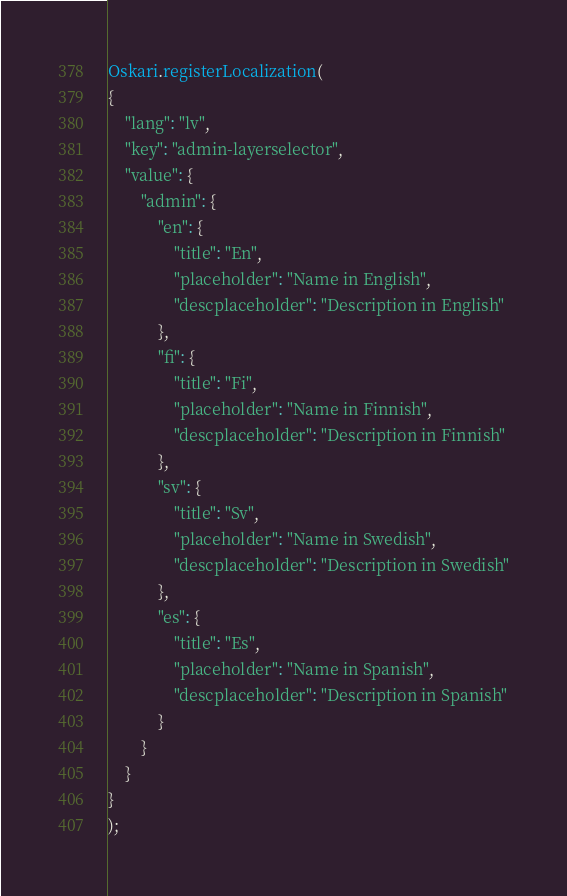<code> <loc_0><loc_0><loc_500><loc_500><_JavaScript_>Oskari.registerLocalization(
{
    "lang": "lv",
    "key": "admin-layerselector",
    "value": {
        "admin": {
            "en": {
                "title": "En",
                "placeholder": "Name in English",
                "descplaceholder": "Description in English"
            },
            "fi": {
                "title": "Fi",
                "placeholder": "Name in Finnish",
                "descplaceholder": "Description in Finnish"
            },
            "sv": {
                "title": "Sv",
                "placeholder": "Name in Swedish",
                "descplaceholder": "Description in Swedish"
            },
            "es": {
                "title": "Es",
                "placeholder": "Name in Spanish",
                "descplaceholder": "Description in Spanish"
            }
        }
    }
}
);</code> 